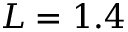<formula> <loc_0><loc_0><loc_500><loc_500>L = 1 . 4</formula> 